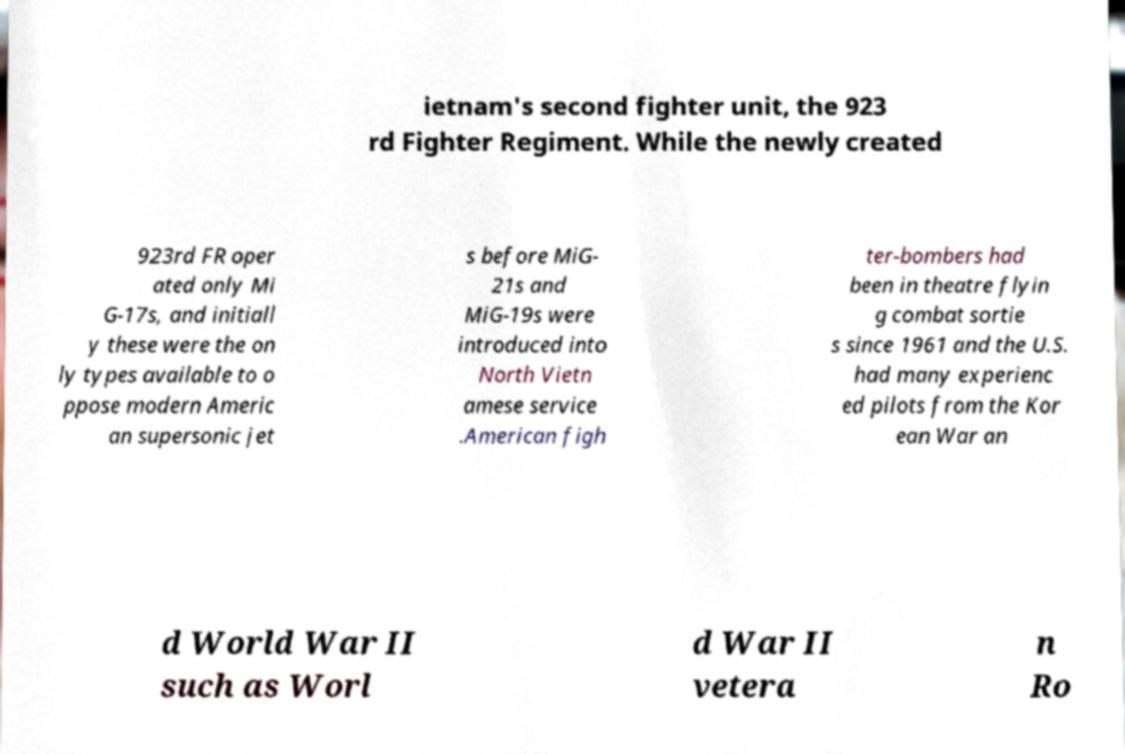Please identify and transcribe the text found in this image. ietnam's second fighter unit, the 923 rd Fighter Regiment. While the newly created 923rd FR oper ated only Mi G-17s, and initiall y these were the on ly types available to o ppose modern Americ an supersonic jet s before MiG- 21s and MiG-19s were introduced into North Vietn amese service .American figh ter-bombers had been in theatre flyin g combat sortie s since 1961 and the U.S. had many experienc ed pilots from the Kor ean War an d World War II such as Worl d War II vetera n Ro 